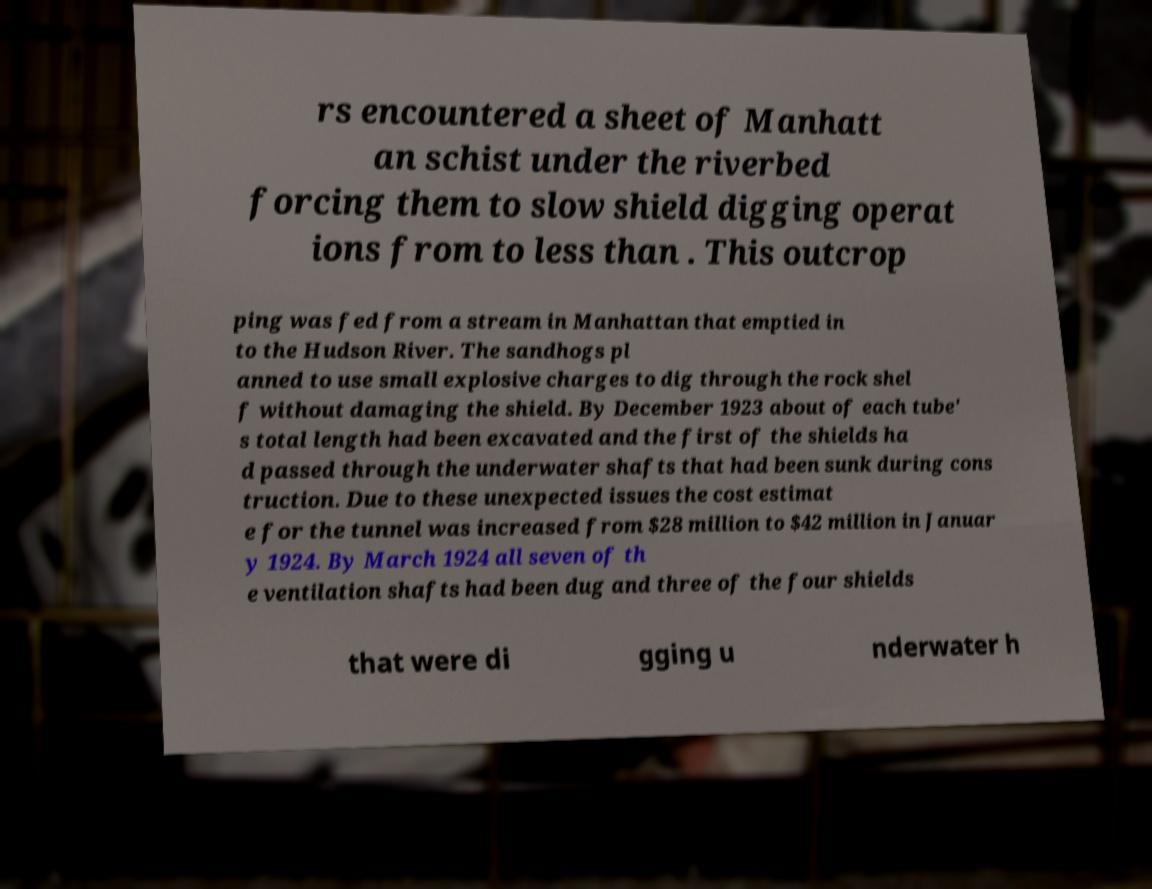Please identify and transcribe the text found in this image. rs encountered a sheet of Manhatt an schist under the riverbed forcing them to slow shield digging operat ions from to less than . This outcrop ping was fed from a stream in Manhattan that emptied in to the Hudson River. The sandhogs pl anned to use small explosive charges to dig through the rock shel f without damaging the shield. By December 1923 about of each tube' s total length had been excavated and the first of the shields ha d passed through the underwater shafts that had been sunk during cons truction. Due to these unexpected issues the cost estimat e for the tunnel was increased from $28 million to $42 million in Januar y 1924. By March 1924 all seven of th e ventilation shafts had been dug and three of the four shields that were di gging u nderwater h 